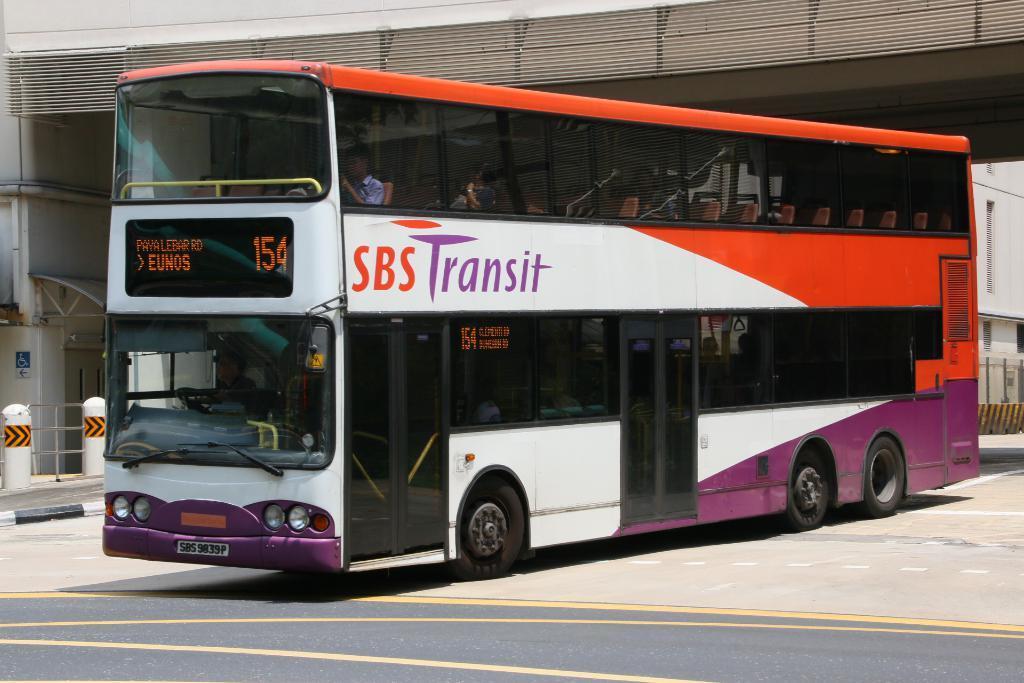Could you give a brief overview of what you see in this image? In this image we can see a bus on the road. We can also see some people inside a bus. On the backside we can see a building, fence, poles and a signboard. 